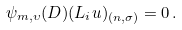<formula> <loc_0><loc_0><loc_500><loc_500>\psi _ { m , \upsilon } ( D ) ( L _ { i } u ) _ { ( n , \sigma ) } = 0 \, .</formula> 